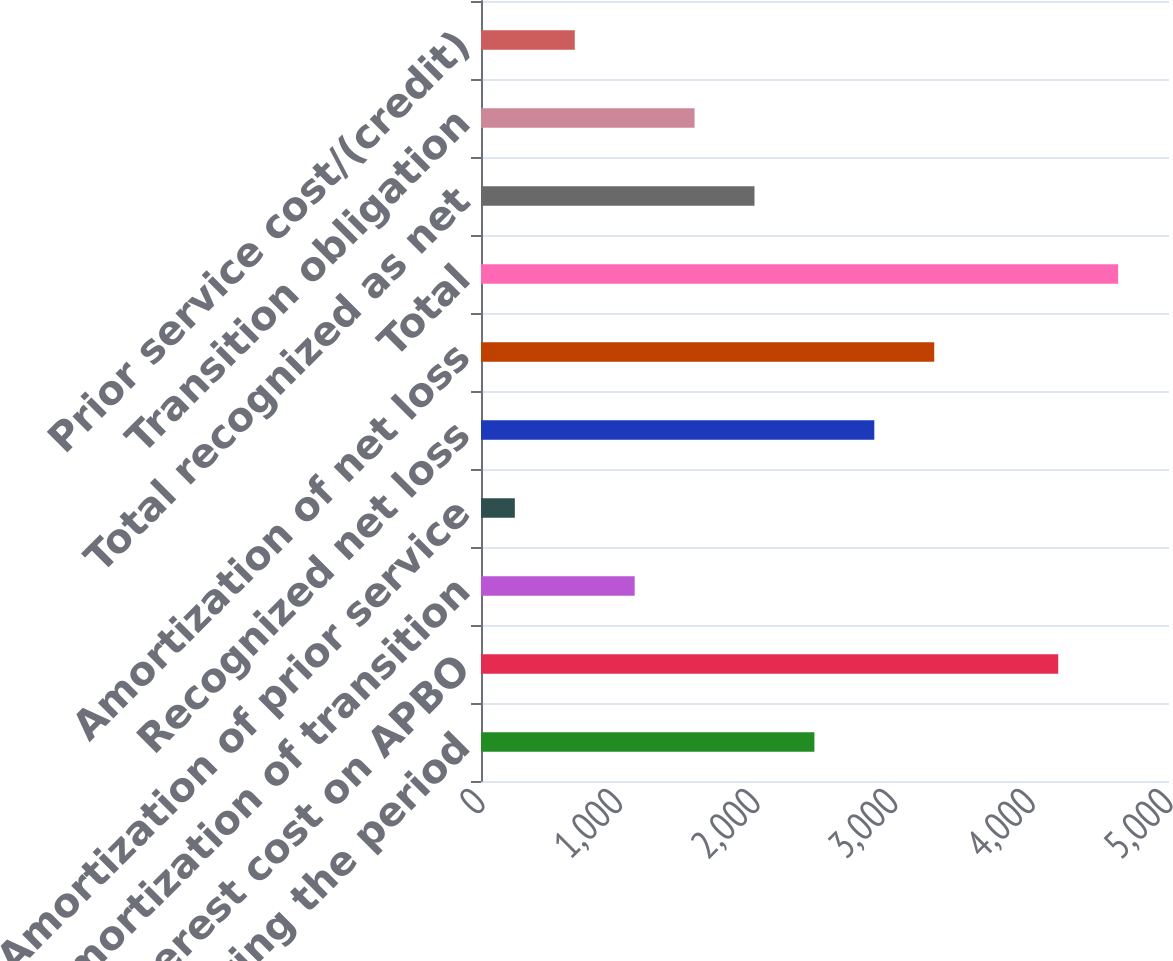Convert chart. <chart><loc_0><loc_0><loc_500><loc_500><bar_chart><fcel>during the period<fcel>Interest cost on APBO<fcel>Amortization of transition<fcel>Amortization of prior service<fcel>Recognized net loss<fcel>Amortization of net loss<fcel>Total<fcel>Total recognized as net<fcel>Transition obligation<fcel>Prior service cost/(credit)<nl><fcel>2423<fcel>4195<fcel>1116.8<fcel>246<fcel>2858.4<fcel>3293.8<fcel>4630.4<fcel>1987.6<fcel>1552.2<fcel>681.4<nl></chart> 